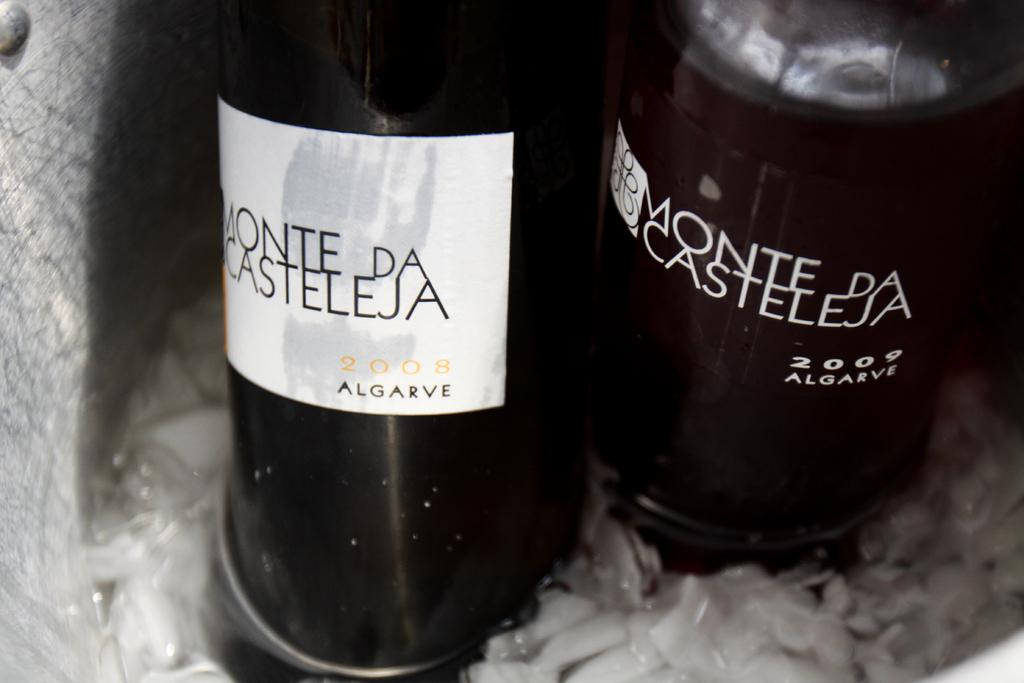<image>
Render a clear and concise summary of the photo. One white bottle of wine that says Monte Da Casteleja and one black bottle of wine that says Monte Da Casteleja. 